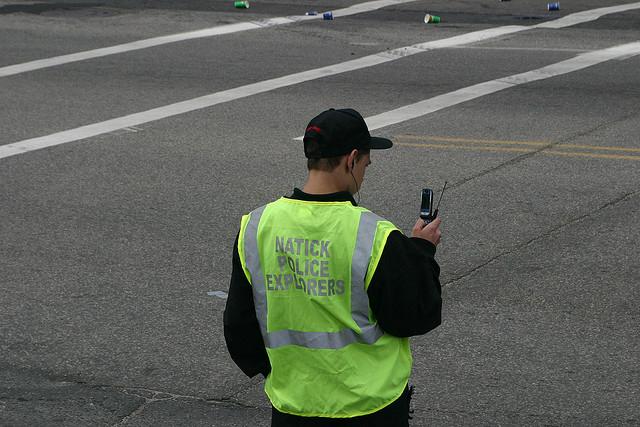What's in the man's ear?
Quick response, please. Earbud. Is this man a firefighter?
Quick response, please. No. What color is his vest?
Write a very short answer. Yellow. 